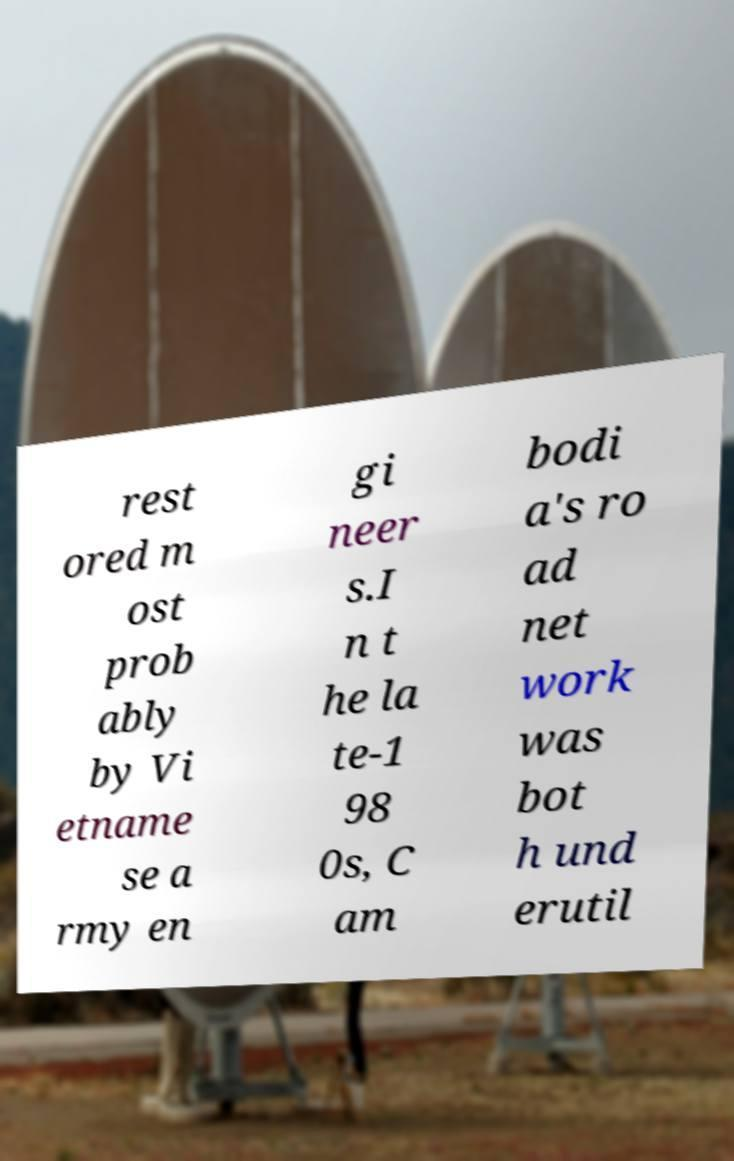Can you accurately transcribe the text from the provided image for me? rest ored m ost prob ably by Vi etname se a rmy en gi neer s.I n t he la te-1 98 0s, C am bodi a's ro ad net work was bot h und erutil 